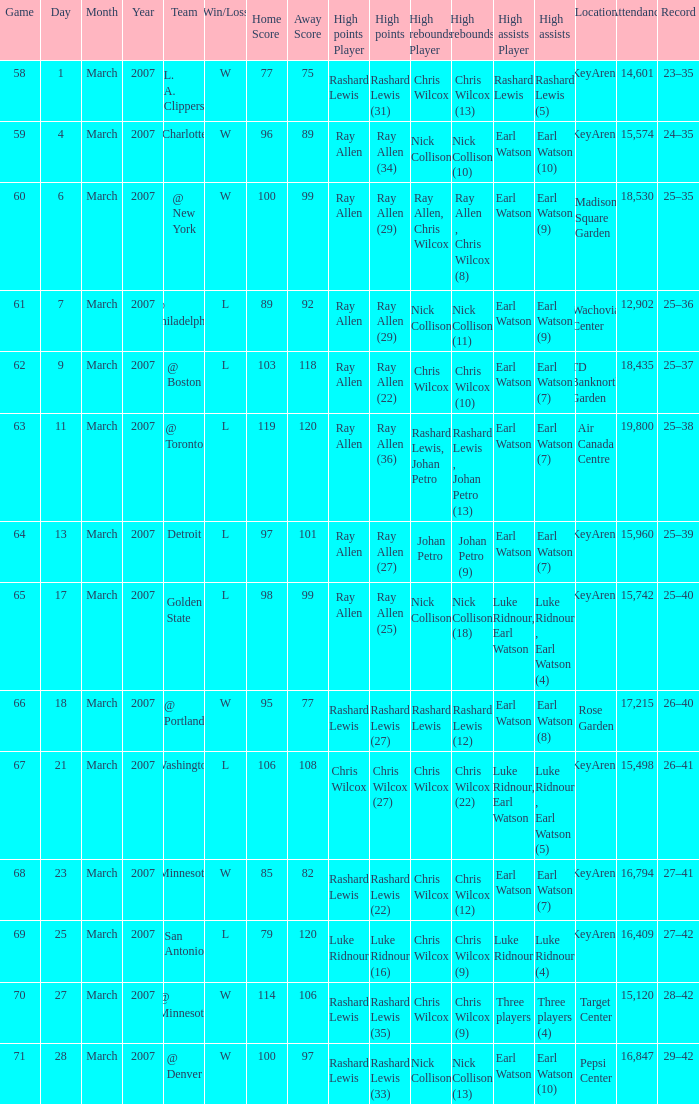Who had the most points in the game on March 7? Ray Allen (29). 